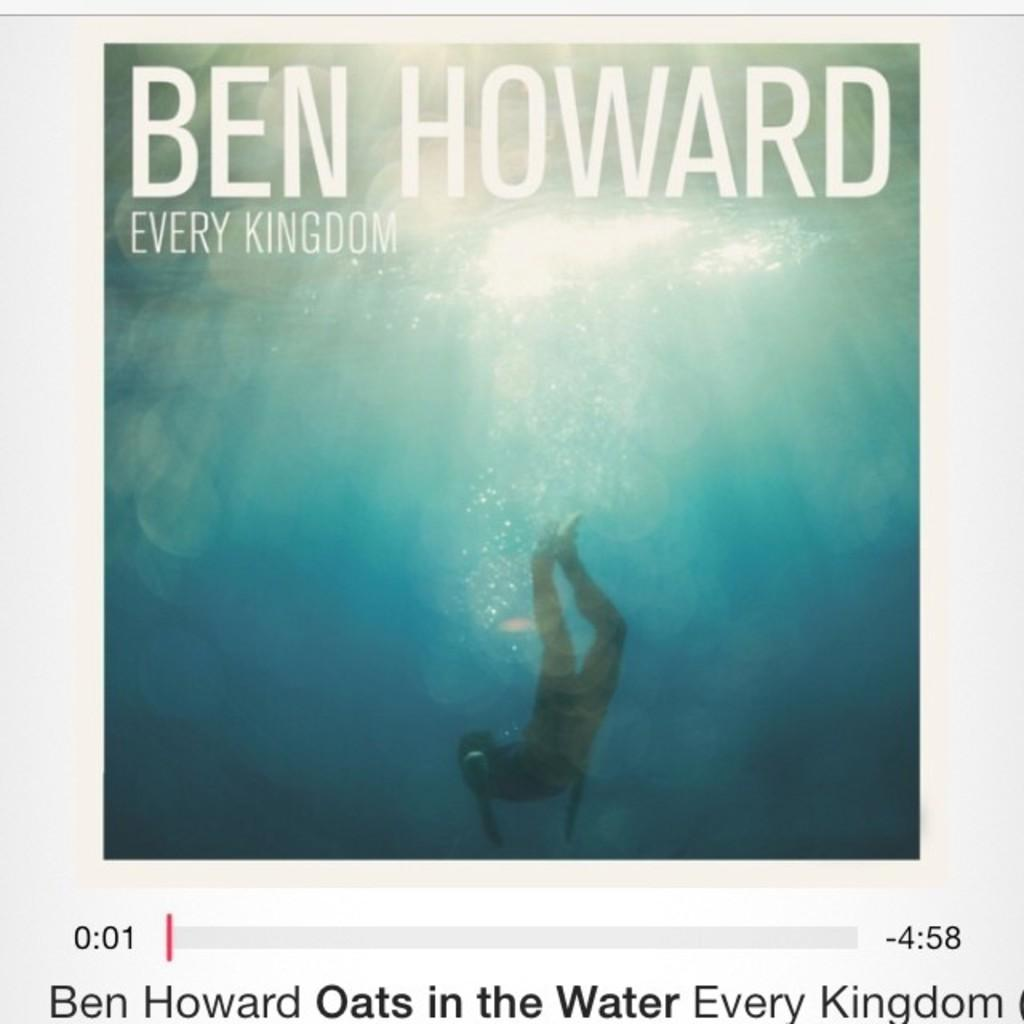<image>
Share a concise interpretation of the image provided. Ben Howard's Every Kingdom album cover with a man swimming underwater 